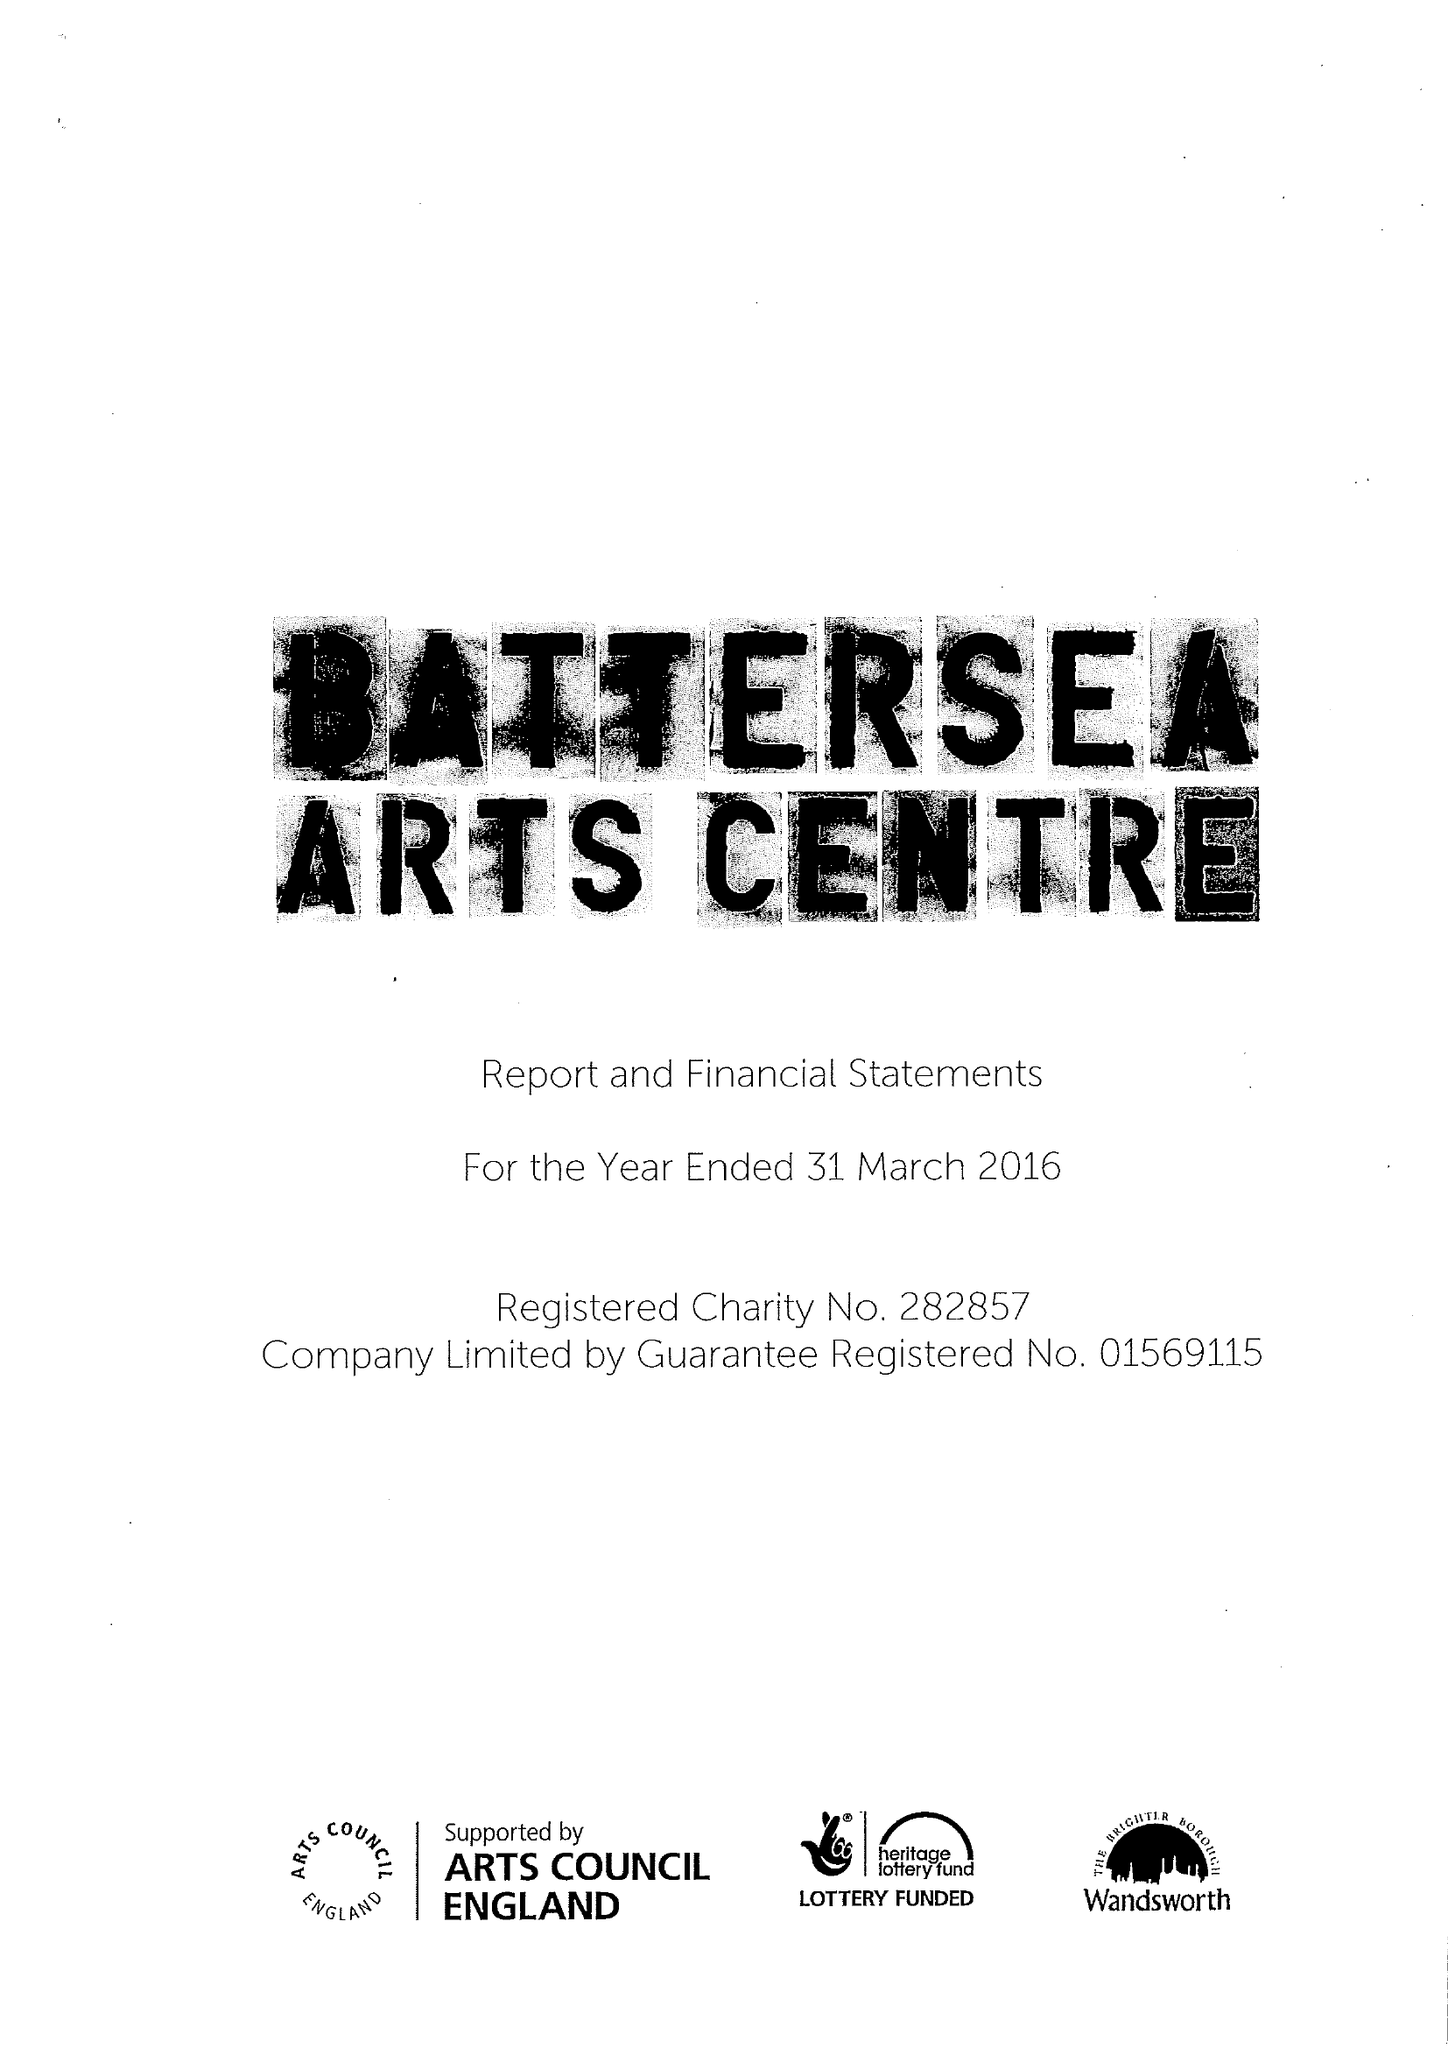What is the value for the income_annually_in_british_pounds?
Answer the question using a single word or phrase. 10060997.00 